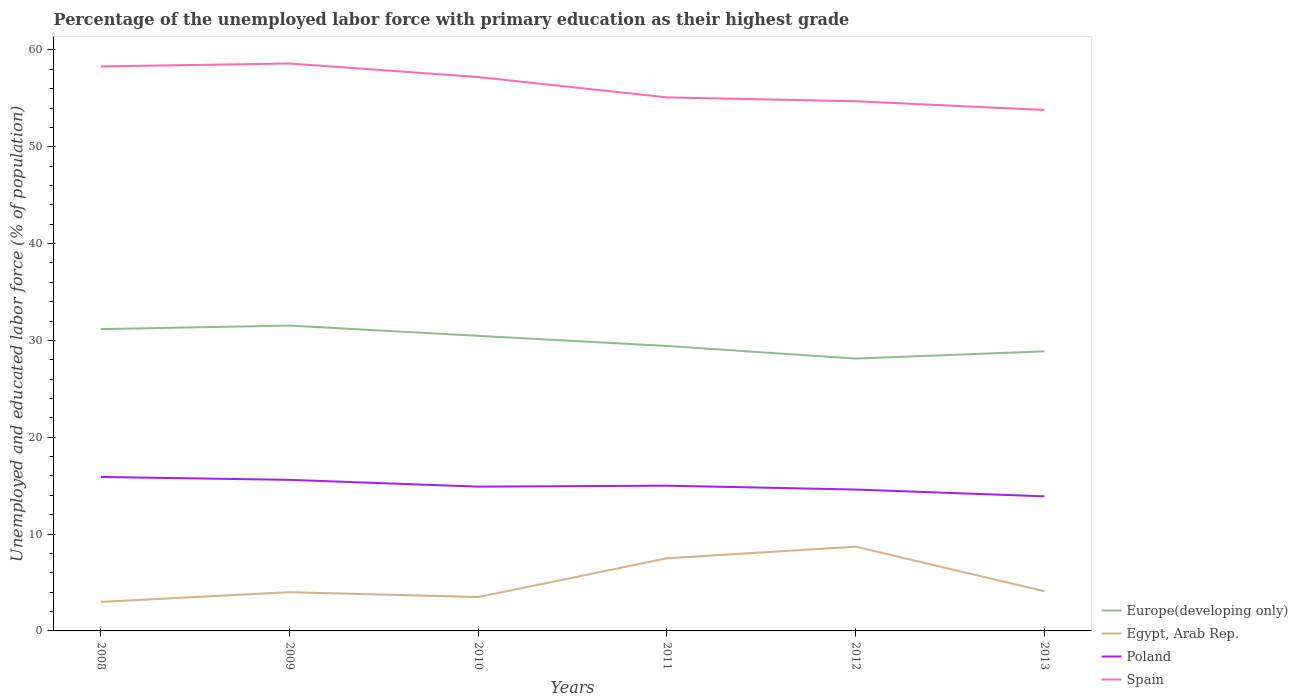How many different coloured lines are there?
Provide a succinct answer. 4. Does the line corresponding to Europe(developing only) intersect with the line corresponding to Spain?
Your answer should be compact. No. Across all years, what is the maximum percentage of the unemployed labor force with primary education in Poland?
Keep it short and to the point. 13.9. In which year was the percentage of the unemployed labor force with primary education in Europe(developing only) maximum?
Your response must be concise. 2012. What is the total percentage of the unemployed labor force with primary education in Europe(developing only) in the graph?
Your answer should be compact. 2.29. What is the difference between the highest and the second highest percentage of the unemployed labor force with primary education in Poland?
Make the answer very short. 2. How many lines are there?
Make the answer very short. 4. How many years are there in the graph?
Make the answer very short. 6. Are the values on the major ticks of Y-axis written in scientific E-notation?
Your answer should be very brief. No. How many legend labels are there?
Your response must be concise. 4. What is the title of the graph?
Provide a succinct answer. Percentage of the unemployed labor force with primary education as their highest grade. Does "Guatemala" appear as one of the legend labels in the graph?
Offer a very short reply. No. What is the label or title of the Y-axis?
Offer a terse response. Unemployed and educated labor force (% of population). What is the Unemployed and educated labor force (% of population) in Europe(developing only) in 2008?
Make the answer very short. 31.17. What is the Unemployed and educated labor force (% of population) in Egypt, Arab Rep. in 2008?
Offer a very short reply. 3. What is the Unemployed and educated labor force (% of population) in Poland in 2008?
Your response must be concise. 15.9. What is the Unemployed and educated labor force (% of population) of Spain in 2008?
Offer a very short reply. 58.3. What is the Unemployed and educated labor force (% of population) in Europe(developing only) in 2009?
Make the answer very short. 31.54. What is the Unemployed and educated labor force (% of population) in Egypt, Arab Rep. in 2009?
Offer a very short reply. 4. What is the Unemployed and educated labor force (% of population) of Poland in 2009?
Make the answer very short. 15.6. What is the Unemployed and educated labor force (% of population) in Spain in 2009?
Make the answer very short. 58.6. What is the Unemployed and educated labor force (% of population) of Europe(developing only) in 2010?
Provide a short and direct response. 30.47. What is the Unemployed and educated labor force (% of population) of Poland in 2010?
Your answer should be very brief. 14.9. What is the Unemployed and educated labor force (% of population) of Spain in 2010?
Offer a terse response. 57.2. What is the Unemployed and educated labor force (% of population) of Europe(developing only) in 2011?
Offer a very short reply. 29.43. What is the Unemployed and educated labor force (% of population) of Spain in 2011?
Provide a succinct answer. 55.1. What is the Unemployed and educated labor force (% of population) in Europe(developing only) in 2012?
Keep it short and to the point. 28.13. What is the Unemployed and educated labor force (% of population) of Egypt, Arab Rep. in 2012?
Your answer should be compact. 8.7. What is the Unemployed and educated labor force (% of population) in Poland in 2012?
Provide a short and direct response. 14.6. What is the Unemployed and educated labor force (% of population) of Spain in 2012?
Your answer should be very brief. 54.7. What is the Unemployed and educated labor force (% of population) of Europe(developing only) in 2013?
Keep it short and to the point. 28.87. What is the Unemployed and educated labor force (% of population) of Egypt, Arab Rep. in 2013?
Offer a very short reply. 4.1. What is the Unemployed and educated labor force (% of population) of Poland in 2013?
Provide a succinct answer. 13.9. What is the Unemployed and educated labor force (% of population) of Spain in 2013?
Offer a terse response. 53.8. Across all years, what is the maximum Unemployed and educated labor force (% of population) of Europe(developing only)?
Your answer should be very brief. 31.54. Across all years, what is the maximum Unemployed and educated labor force (% of population) of Egypt, Arab Rep.?
Your answer should be compact. 8.7. Across all years, what is the maximum Unemployed and educated labor force (% of population) of Poland?
Keep it short and to the point. 15.9. Across all years, what is the maximum Unemployed and educated labor force (% of population) in Spain?
Offer a terse response. 58.6. Across all years, what is the minimum Unemployed and educated labor force (% of population) in Europe(developing only)?
Give a very brief answer. 28.13. Across all years, what is the minimum Unemployed and educated labor force (% of population) in Egypt, Arab Rep.?
Provide a succinct answer. 3. Across all years, what is the minimum Unemployed and educated labor force (% of population) in Poland?
Provide a short and direct response. 13.9. Across all years, what is the minimum Unemployed and educated labor force (% of population) in Spain?
Ensure brevity in your answer.  53.8. What is the total Unemployed and educated labor force (% of population) of Europe(developing only) in the graph?
Offer a very short reply. 179.6. What is the total Unemployed and educated labor force (% of population) of Egypt, Arab Rep. in the graph?
Offer a very short reply. 30.8. What is the total Unemployed and educated labor force (% of population) in Poland in the graph?
Offer a very short reply. 89.9. What is the total Unemployed and educated labor force (% of population) of Spain in the graph?
Your answer should be compact. 337.7. What is the difference between the Unemployed and educated labor force (% of population) in Europe(developing only) in 2008 and that in 2009?
Your answer should be very brief. -0.37. What is the difference between the Unemployed and educated labor force (% of population) of Egypt, Arab Rep. in 2008 and that in 2009?
Give a very brief answer. -1. What is the difference between the Unemployed and educated labor force (% of population) in Poland in 2008 and that in 2009?
Offer a very short reply. 0.3. What is the difference between the Unemployed and educated labor force (% of population) in Spain in 2008 and that in 2009?
Your answer should be compact. -0.3. What is the difference between the Unemployed and educated labor force (% of population) of Europe(developing only) in 2008 and that in 2010?
Your answer should be compact. 0.69. What is the difference between the Unemployed and educated labor force (% of population) in Poland in 2008 and that in 2010?
Your response must be concise. 1. What is the difference between the Unemployed and educated labor force (% of population) in Spain in 2008 and that in 2010?
Offer a very short reply. 1.1. What is the difference between the Unemployed and educated labor force (% of population) of Europe(developing only) in 2008 and that in 2011?
Offer a terse response. 1.74. What is the difference between the Unemployed and educated labor force (% of population) in Poland in 2008 and that in 2011?
Offer a very short reply. 0.9. What is the difference between the Unemployed and educated labor force (% of population) in Europe(developing only) in 2008 and that in 2012?
Ensure brevity in your answer.  3.04. What is the difference between the Unemployed and educated labor force (% of population) in Europe(developing only) in 2008 and that in 2013?
Your response must be concise. 2.29. What is the difference between the Unemployed and educated labor force (% of population) in Egypt, Arab Rep. in 2008 and that in 2013?
Give a very brief answer. -1.1. What is the difference between the Unemployed and educated labor force (% of population) of Spain in 2008 and that in 2013?
Ensure brevity in your answer.  4.5. What is the difference between the Unemployed and educated labor force (% of population) of Europe(developing only) in 2009 and that in 2010?
Offer a terse response. 1.06. What is the difference between the Unemployed and educated labor force (% of population) in Egypt, Arab Rep. in 2009 and that in 2010?
Offer a very short reply. 0.5. What is the difference between the Unemployed and educated labor force (% of population) of Spain in 2009 and that in 2010?
Ensure brevity in your answer.  1.4. What is the difference between the Unemployed and educated labor force (% of population) of Europe(developing only) in 2009 and that in 2011?
Your answer should be compact. 2.11. What is the difference between the Unemployed and educated labor force (% of population) in Egypt, Arab Rep. in 2009 and that in 2011?
Ensure brevity in your answer.  -3.5. What is the difference between the Unemployed and educated labor force (% of population) of Spain in 2009 and that in 2011?
Your answer should be very brief. 3.5. What is the difference between the Unemployed and educated labor force (% of population) in Europe(developing only) in 2009 and that in 2012?
Give a very brief answer. 3.41. What is the difference between the Unemployed and educated labor force (% of population) of Egypt, Arab Rep. in 2009 and that in 2012?
Offer a very short reply. -4.7. What is the difference between the Unemployed and educated labor force (% of population) in Poland in 2009 and that in 2012?
Keep it short and to the point. 1. What is the difference between the Unemployed and educated labor force (% of population) in Europe(developing only) in 2009 and that in 2013?
Make the answer very short. 2.66. What is the difference between the Unemployed and educated labor force (% of population) of Egypt, Arab Rep. in 2009 and that in 2013?
Ensure brevity in your answer.  -0.1. What is the difference between the Unemployed and educated labor force (% of population) of Europe(developing only) in 2010 and that in 2011?
Ensure brevity in your answer.  1.04. What is the difference between the Unemployed and educated labor force (% of population) in Egypt, Arab Rep. in 2010 and that in 2011?
Your answer should be very brief. -4. What is the difference between the Unemployed and educated labor force (% of population) in Spain in 2010 and that in 2011?
Offer a very short reply. 2.1. What is the difference between the Unemployed and educated labor force (% of population) in Europe(developing only) in 2010 and that in 2012?
Your answer should be compact. 2.35. What is the difference between the Unemployed and educated labor force (% of population) of Spain in 2010 and that in 2012?
Offer a very short reply. 2.5. What is the difference between the Unemployed and educated labor force (% of population) in Europe(developing only) in 2010 and that in 2013?
Your answer should be very brief. 1.6. What is the difference between the Unemployed and educated labor force (% of population) of Poland in 2010 and that in 2013?
Your answer should be compact. 1. What is the difference between the Unemployed and educated labor force (% of population) in Europe(developing only) in 2011 and that in 2012?
Your response must be concise. 1.3. What is the difference between the Unemployed and educated labor force (% of population) of Egypt, Arab Rep. in 2011 and that in 2012?
Your response must be concise. -1.2. What is the difference between the Unemployed and educated labor force (% of population) in Poland in 2011 and that in 2012?
Offer a very short reply. 0.4. What is the difference between the Unemployed and educated labor force (% of population) of Europe(developing only) in 2011 and that in 2013?
Offer a very short reply. 0.55. What is the difference between the Unemployed and educated labor force (% of population) in Egypt, Arab Rep. in 2011 and that in 2013?
Provide a short and direct response. 3.4. What is the difference between the Unemployed and educated labor force (% of population) in Poland in 2011 and that in 2013?
Make the answer very short. 1.1. What is the difference between the Unemployed and educated labor force (% of population) of Spain in 2011 and that in 2013?
Provide a short and direct response. 1.3. What is the difference between the Unemployed and educated labor force (% of population) in Europe(developing only) in 2012 and that in 2013?
Keep it short and to the point. -0.75. What is the difference between the Unemployed and educated labor force (% of population) in Poland in 2012 and that in 2013?
Ensure brevity in your answer.  0.7. What is the difference between the Unemployed and educated labor force (% of population) of Spain in 2012 and that in 2013?
Offer a terse response. 0.9. What is the difference between the Unemployed and educated labor force (% of population) in Europe(developing only) in 2008 and the Unemployed and educated labor force (% of population) in Egypt, Arab Rep. in 2009?
Offer a very short reply. 27.17. What is the difference between the Unemployed and educated labor force (% of population) of Europe(developing only) in 2008 and the Unemployed and educated labor force (% of population) of Poland in 2009?
Offer a very short reply. 15.57. What is the difference between the Unemployed and educated labor force (% of population) of Europe(developing only) in 2008 and the Unemployed and educated labor force (% of population) of Spain in 2009?
Your answer should be compact. -27.43. What is the difference between the Unemployed and educated labor force (% of population) of Egypt, Arab Rep. in 2008 and the Unemployed and educated labor force (% of population) of Spain in 2009?
Keep it short and to the point. -55.6. What is the difference between the Unemployed and educated labor force (% of population) in Poland in 2008 and the Unemployed and educated labor force (% of population) in Spain in 2009?
Your answer should be compact. -42.7. What is the difference between the Unemployed and educated labor force (% of population) in Europe(developing only) in 2008 and the Unemployed and educated labor force (% of population) in Egypt, Arab Rep. in 2010?
Provide a short and direct response. 27.67. What is the difference between the Unemployed and educated labor force (% of population) of Europe(developing only) in 2008 and the Unemployed and educated labor force (% of population) of Poland in 2010?
Keep it short and to the point. 16.27. What is the difference between the Unemployed and educated labor force (% of population) of Europe(developing only) in 2008 and the Unemployed and educated labor force (% of population) of Spain in 2010?
Your answer should be compact. -26.03. What is the difference between the Unemployed and educated labor force (% of population) in Egypt, Arab Rep. in 2008 and the Unemployed and educated labor force (% of population) in Spain in 2010?
Provide a succinct answer. -54.2. What is the difference between the Unemployed and educated labor force (% of population) in Poland in 2008 and the Unemployed and educated labor force (% of population) in Spain in 2010?
Your answer should be very brief. -41.3. What is the difference between the Unemployed and educated labor force (% of population) in Europe(developing only) in 2008 and the Unemployed and educated labor force (% of population) in Egypt, Arab Rep. in 2011?
Your answer should be compact. 23.67. What is the difference between the Unemployed and educated labor force (% of population) in Europe(developing only) in 2008 and the Unemployed and educated labor force (% of population) in Poland in 2011?
Offer a terse response. 16.17. What is the difference between the Unemployed and educated labor force (% of population) in Europe(developing only) in 2008 and the Unemployed and educated labor force (% of population) in Spain in 2011?
Offer a terse response. -23.93. What is the difference between the Unemployed and educated labor force (% of population) in Egypt, Arab Rep. in 2008 and the Unemployed and educated labor force (% of population) in Poland in 2011?
Offer a very short reply. -12. What is the difference between the Unemployed and educated labor force (% of population) in Egypt, Arab Rep. in 2008 and the Unemployed and educated labor force (% of population) in Spain in 2011?
Your answer should be very brief. -52.1. What is the difference between the Unemployed and educated labor force (% of population) in Poland in 2008 and the Unemployed and educated labor force (% of population) in Spain in 2011?
Offer a very short reply. -39.2. What is the difference between the Unemployed and educated labor force (% of population) in Europe(developing only) in 2008 and the Unemployed and educated labor force (% of population) in Egypt, Arab Rep. in 2012?
Provide a short and direct response. 22.47. What is the difference between the Unemployed and educated labor force (% of population) in Europe(developing only) in 2008 and the Unemployed and educated labor force (% of population) in Poland in 2012?
Your answer should be very brief. 16.57. What is the difference between the Unemployed and educated labor force (% of population) of Europe(developing only) in 2008 and the Unemployed and educated labor force (% of population) of Spain in 2012?
Keep it short and to the point. -23.53. What is the difference between the Unemployed and educated labor force (% of population) of Egypt, Arab Rep. in 2008 and the Unemployed and educated labor force (% of population) of Poland in 2012?
Your answer should be very brief. -11.6. What is the difference between the Unemployed and educated labor force (% of population) of Egypt, Arab Rep. in 2008 and the Unemployed and educated labor force (% of population) of Spain in 2012?
Offer a terse response. -51.7. What is the difference between the Unemployed and educated labor force (% of population) in Poland in 2008 and the Unemployed and educated labor force (% of population) in Spain in 2012?
Your response must be concise. -38.8. What is the difference between the Unemployed and educated labor force (% of population) in Europe(developing only) in 2008 and the Unemployed and educated labor force (% of population) in Egypt, Arab Rep. in 2013?
Provide a short and direct response. 27.07. What is the difference between the Unemployed and educated labor force (% of population) in Europe(developing only) in 2008 and the Unemployed and educated labor force (% of population) in Poland in 2013?
Give a very brief answer. 17.27. What is the difference between the Unemployed and educated labor force (% of population) in Europe(developing only) in 2008 and the Unemployed and educated labor force (% of population) in Spain in 2013?
Provide a succinct answer. -22.63. What is the difference between the Unemployed and educated labor force (% of population) in Egypt, Arab Rep. in 2008 and the Unemployed and educated labor force (% of population) in Poland in 2013?
Your answer should be very brief. -10.9. What is the difference between the Unemployed and educated labor force (% of population) in Egypt, Arab Rep. in 2008 and the Unemployed and educated labor force (% of population) in Spain in 2013?
Make the answer very short. -50.8. What is the difference between the Unemployed and educated labor force (% of population) of Poland in 2008 and the Unemployed and educated labor force (% of population) of Spain in 2013?
Give a very brief answer. -37.9. What is the difference between the Unemployed and educated labor force (% of population) of Europe(developing only) in 2009 and the Unemployed and educated labor force (% of population) of Egypt, Arab Rep. in 2010?
Your answer should be very brief. 28.04. What is the difference between the Unemployed and educated labor force (% of population) of Europe(developing only) in 2009 and the Unemployed and educated labor force (% of population) of Poland in 2010?
Ensure brevity in your answer.  16.64. What is the difference between the Unemployed and educated labor force (% of population) in Europe(developing only) in 2009 and the Unemployed and educated labor force (% of population) in Spain in 2010?
Give a very brief answer. -25.66. What is the difference between the Unemployed and educated labor force (% of population) in Egypt, Arab Rep. in 2009 and the Unemployed and educated labor force (% of population) in Spain in 2010?
Your answer should be very brief. -53.2. What is the difference between the Unemployed and educated labor force (% of population) in Poland in 2009 and the Unemployed and educated labor force (% of population) in Spain in 2010?
Provide a short and direct response. -41.6. What is the difference between the Unemployed and educated labor force (% of population) of Europe(developing only) in 2009 and the Unemployed and educated labor force (% of population) of Egypt, Arab Rep. in 2011?
Provide a succinct answer. 24.04. What is the difference between the Unemployed and educated labor force (% of population) of Europe(developing only) in 2009 and the Unemployed and educated labor force (% of population) of Poland in 2011?
Offer a very short reply. 16.54. What is the difference between the Unemployed and educated labor force (% of population) in Europe(developing only) in 2009 and the Unemployed and educated labor force (% of population) in Spain in 2011?
Keep it short and to the point. -23.56. What is the difference between the Unemployed and educated labor force (% of population) of Egypt, Arab Rep. in 2009 and the Unemployed and educated labor force (% of population) of Poland in 2011?
Provide a succinct answer. -11. What is the difference between the Unemployed and educated labor force (% of population) of Egypt, Arab Rep. in 2009 and the Unemployed and educated labor force (% of population) of Spain in 2011?
Offer a terse response. -51.1. What is the difference between the Unemployed and educated labor force (% of population) of Poland in 2009 and the Unemployed and educated labor force (% of population) of Spain in 2011?
Your answer should be compact. -39.5. What is the difference between the Unemployed and educated labor force (% of population) in Europe(developing only) in 2009 and the Unemployed and educated labor force (% of population) in Egypt, Arab Rep. in 2012?
Your answer should be compact. 22.84. What is the difference between the Unemployed and educated labor force (% of population) in Europe(developing only) in 2009 and the Unemployed and educated labor force (% of population) in Poland in 2012?
Make the answer very short. 16.94. What is the difference between the Unemployed and educated labor force (% of population) of Europe(developing only) in 2009 and the Unemployed and educated labor force (% of population) of Spain in 2012?
Your response must be concise. -23.16. What is the difference between the Unemployed and educated labor force (% of population) of Egypt, Arab Rep. in 2009 and the Unemployed and educated labor force (% of population) of Spain in 2012?
Ensure brevity in your answer.  -50.7. What is the difference between the Unemployed and educated labor force (% of population) of Poland in 2009 and the Unemployed and educated labor force (% of population) of Spain in 2012?
Provide a succinct answer. -39.1. What is the difference between the Unemployed and educated labor force (% of population) in Europe(developing only) in 2009 and the Unemployed and educated labor force (% of population) in Egypt, Arab Rep. in 2013?
Make the answer very short. 27.44. What is the difference between the Unemployed and educated labor force (% of population) in Europe(developing only) in 2009 and the Unemployed and educated labor force (% of population) in Poland in 2013?
Your answer should be compact. 17.64. What is the difference between the Unemployed and educated labor force (% of population) in Europe(developing only) in 2009 and the Unemployed and educated labor force (% of population) in Spain in 2013?
Your answer should be compact. -22.26. What is the difference between the Unemployed and educated labor force (% of population) in Egypt, Arab Rep. in 2009 and the Unemployed and educated labor force (% of population) in Spain in 2013?
Make the answer very short. -49.8. What is the difference between the Unemployed and educated labor force (% of population) of Poland in 2009 and the Unemployed and educated labor force (% of population) of Spain in 2013?
Make the answer very short. -38.2. What is the difference between the Unemployed and educated labor force (% of population) in Europe(developing only) in 2010 and the Unemployed and educated labor force (% of population) in Egypt, Arab Rep. in 2011?
Make the answer very short. 22.97. What is the difference between the Unemployed and educated labor force (% of population) in Europe(developing only) in 2010 and the Unemployed and educated labor force (% of population) in Poland in 2011?
Your answer should be compact. 15.47. What is the difference between the Unemployed and educated labor force (% of population) in Europe(developing only) in 2010 and the Unemployed and educated labor force (% of population) in Spain in 2011?
Offer a terse response. -24.63. What is the difference between the Unemployed and educated labor force (% of population) in Egypt, Arab Rep. in 2010 and the Unemployed and educated labor force (% of population) in Poland in 2011?
Provide a short and direct response. -11.5. What is the difference between the Unemployed and educated labor force (% of population) of Egypt, Arab Rep. in 2010 and the Unemployed and educated labor force (% of population) of Spain in 2011?
Your response must be concise. -51.6. What is the difference between the Unemployed and educated labor force (% of population) of Poland in 2010 and the Unemployed and educated labor force (% of population) of Spain in 2011?
Ensure brevity in your answer.  -40.2. What is the difference between the Unemployed and educated labor force (% of population) in Europe(developing only) in 2010 and the Unemployed and educated labor force (% of population) in Egypt, Arab Rep. in 2012?
Ensure brevity in your answer.  21.77. What is the difference between the Unemployed and educated labor force (% of population) of Europe(developing only) in 2010 and the Unemployed and educated labor force (% of population) of Poland in 2012?
Give a very brief answer. 15.87. What is the difference between the Unemployed and educated labor force (% of population) in Europe(developing only) in 2010 and the Unemployed and educated labor force (% of population) in Spain in 2012?
Ensure brevity in your answer.  -24.23. What is the difference between the Unemployed and educated labor force (% of population) of Egypt, Arab Rep. in 2010 and the Unemployed and educated labor force (% of population) of Spain in 2012?
Your answer should be very brief. -51.2. What is the difference between the Unemployed and educated labor force (% of population) of Poland in 2010 and the Unemployed and educated labor force (% of population) of Spain in 2012?
Your response must be concise. -39.8. What is the difference between the Unemployed and educated labor force (% of population) of Europe(developing only) in 2010 and the Unemployed and educated labor force (% of population) of Egypt, Arab Rep. in 2013?
Ensure brevity in your answer.  26.37. What is the difference between the Unemployed and educated labor force (% of population) of Europe(developing only) in 2010 and the Unemployed and educated labor force (% of population) of Poland in 2013?
Provide a succinct answer. 16.57. What is the difference between the Unemployed and educated labor force (% of population) of Europe(developing only) in 2010 and the Unemployed and educated labor force (% of population) of Spain in 2013?
Provide a short and direct response. -23.33. What is the difference between the Unemployed and educated labor force (% of population) in Egypt, Arab Rep. in 2010 and the Unemployed and educated labor force (% of population) in Poland in 2013?
Give a very brief answer. -10.4. What is the difference between the Unemployed and educated labor force (% of population) of Egypt, Arab Rep. in 2010 and the Unemployed and educated labor force (% of population) of Spain in 2013?
Ensure brevity in your answer.  -50.3. What is the difference between the Unemployed and educated labor force (% of population) of Poland in 2010 and the Unemployed and educated labor force (% of population) of Spain in 2013?
Offer a terse response. -38.9. What is the difference between the Unemployed and educated labor force (% of population) of Europe(developing only) in 2011 and the Unemployed and educated labor force (% of population) of Egypt, Arab Rep. in 2012?
Make the answer very short. 20.73. What is the difference between the Unemployed and educated labor force (% of population) of Europe(developing only) in 2011 and the Unemployed and educated labor force (% of population) of Poland in 2012?
Make the answer very short. 14.83. What is the difference between the Unemployed and educated labor force (% of population) of Europe(developing only) in 2011 and the Unemployed and educated labor force (% of population) of Spain in 2012?
Your answer should be compact. -25.27. What is the difference between the Unemployed and educated labor force (% of population) in Egypt, Arab Rep. in 2011 and the Unemployed and educated labor force (% of population) in Poland in 2012?
Your response must be concise. -7.1. What is the difference between the Unemployed and educated labor force (% of population) of Egypt, Arab Rep. in 2011 and the Unemployed and educated labor force (% of population) of Spain in 2012?
Offer a terse response. -47.2. What is the difference between the Unemployed and educated labor force (% of population) in Poland in 2011 and the Unemployed and educated labor force (% of population) in Spain in 2012?
Offer a terse response. -39.7. What is the difference between the Unemployed and educated labor force (% of population) of Europe(developing only) in 2011 and the Unemployed and educated labor force (% of population) of Egypt, Arab Rep. in 2013?
Ensure brevity in your answer.  25.33. What is the difference between the Unemployed and educated labor force (% of population) in Europe(developing only) in 2011 and the Unemployed and educated labor force (% of population) in Poland in 2013?
Make the answer very short. 15.53. What is the difference between the Unemployed and educated labor force (% of population) in Europe(developing only) in 2011 and the Unemployed and educated labor force (% of population) in Spain in 2013?
Your answer should be compact. -24.37. What is the difference between the Unemployed and educated labor force (% of population) of Egypt, Arab Rep. in 2011 and the Unemployed and educated labor force (% of population) of Poland in 2013?
Your response must be concise. -6.4. What is the difference between the Unemployed and educated labor force (% of population) of Egypt, Arab Rep. in 2011 and the Unemployed and educated labor force (% of population) of Spain in 2013?
Ensure brevity in your answer.  -46.3. What is the difference between the Unemployed and educated labor force (% of population) in Poland in 2011 and the Unemployed and educated labor force (% of population) in Spain in 2013?
Keep it short and to the point. -38.8. What is the difference between the Unemployed and educated labor force (% of population) in Europe(developing only) in 2012 and the Unemployed and educated labor force (% of population) in Egypt, Arab Rep. in 2013?
Make the answer very short. 24.03. What is the difference between the Unemployed and educated labor force (% of population) of Europe(developing only) in 2012 and the Unemployed and educated labor force (% of population) of Poland in 2013?
Make the answer very short. 14.23. What is the difference between the Unemployed and educated labor force (% of population) of Europe(developing only) in 2012 and the Unemployed and educated labor force (% of population) of Spain in 2013?
Your response must be concise. -25.67. What is the difference between the Unemployed and educated labor force (% of population) in Egypt, Arab Rep. in 2012 and the Unemployed and educated labor force (% of population) in Poland in 2013?
Your answer should be very brief. -5.2. What is the difference between the Unemployed and educated labor force (% of population) of Egypt, Arab Rep. in 2012 and the Unemployed and educated labor force (% of population) of Spain in 2013?
Give a very brief answer. -45.1. What is the difference between the Unemployed and educated labor force (% of population) of Poland in 2012 and the Unemployed and educated labor force (% of population) of Spain in 2013?
Provide a succinct answer. -39.2. What is the average Unemployed and educated labor force (% of population) of Europe(developing only) per year?
Give a very brief answer. 29.93. What is the average Unemployed and educated labor force (% of population) in Egypt, Arab Rep. per year?
Offer a very short reply. 5.13. What is the average Unemployed and educated labor force (% of population) in Poland per year?
Offer a very short reply. 14.98. What is the average Unemployed and educated labor force (% of population) in Spain per year?
Make the answer very short. 56.28. In the year 2008, what is the difference between the Unemployed and educated labor force (% of population) of Europe(developing only) and Unemployed and educated labor force (% of population) of Egypt, Arab Rep.?
Keep it short and to the point. 28.17. In the year 2008, what is the difference between the Unemployed and educated labor force (% of population) in Europe(developing only) and Unemployed and educated labor force (% of population) in Poland?
Ensure brevity in your answer.  15.27. In the year 2008, what is the difference between the Unemployed and educated labor force (% of population) in Europe(developing only) and Unemployed and educated labor force (% of population) in Spain?
Your answer should be very brief. -27.13. In the year 2008, what is the difference between the Unemployed and educated labor force (% of population) of Egypt, Arab Rep. and Unemployed and educated labor force (% of population) of Spain?
Ensure brevity in your answer.  -55.3. In the year 2008, what is the difference between the Unemployed and educated labor force (% of population) in Poland and Unemployed and educated labor force (% of population) in Spain?
Offer a terse response. -42.4. In the year 2009, what is the difference between the Unemployed and educated labor force (% of population) of Europe(developing only) and Unemployed and educated labor force (% of population) of Egypt, Arab Rep.?
Give a very brief answer. 27.54. In the year 2009, what is the difference between the Unemployed and educated labor force (% of population) in Europe(developing only) and Unemployed and educated labor force (% of population) in Poland?
Your response must be concise. 15.94. In the year 2009, what is the difference between the Unemployed and educated labor force (% of population) of Europe(developing only) and Unemployed and educated labor force (% of population) of Spain?
Your answer should be compact. -27.06. In the year 2009, what is the difference between the Unemployed and educated labor force (% of population) in Egypt, Arab Rep. and Unemployed and educated labor force (% of population) in Poland?
Provide a succinct answer. -11.6. In the year 2009, what is the difference between the Unemployed and educated labor force (% of population) of Egypt, Arab Rep. and Unemployed and educated labor force (% of population) of Spain?
Ensure brevity in your answer.  -54.6. In the year 2009, what is the difference between the Unemployed and educated labor force (% of population) of Poland and Unemployed and educated labor force (% of population) of Spain?
Your answer should be very brief. -43. In the year 2010, what is the difference between the Unemployed and educated labor force (% of population) of Europe(developing only) and Unemployed and educated labor force (% of population) of Egypt, Arab Rep.?
Ensure brevity in your answer.  26.97. In the year 2010, what is the difference between the Unemployed and educated labor force (% of population) of Europe(developing only) and Unemployed and educated labor force (% of population) of Poland?
Your answer should be compact. 15.57. In the year 2010, what is the difference between the Unemployed and educated labor force (% of population) of Europe(developing only) and Unemployed and educated labor force (% of population) of Spain?
Provide a short and direct response. -26.73. In the year 2010, what is the difference between the Unemployed and educated labor force (% of population) of Egypt, Arab Rep. and Unemployed and educated labor force (% of population) of Spain?
Your response must be concise. -53.7. In the year 2010, what is the difference between the Unemployed and educated labor force (% of population) of Poland and Unemployed and educated labor force (% of population) of Spain?
Your response must be concise. -42.3. In the year 2011, what is the difference between the Unemployed and educated labor force (% of population) of Europe(developing only) and Unemployed and educated labor force (% of population) of Egypt, Arab Rep.?
Provide a succinct answer. 21.93. In the year 2011, what is the difference between the Unemployed and educated labor force (% of population) of Europe(developing only) and Unemployed and educated labor force (% of population) of Poland?
Your answer should be very brief. 14.43. In the year 2011, what is the difference between the Unemployed and educated labor force (% of population) of Europe(developing only) and Unemployed and educated labor force (% of population) of Spain?
Your answer should be very brief. -25.67. In the year 2011, what is the difference between the Unemployed and educated labor force (% of population) in Egypt, Arab Rep. and Unemployed and educated labor force (% of population) in Spain?
Provide a succinct answer. -47.6. In the year 2011, what is the difference between the Unemployed and educated labor force (% of population) of Poland and Unemployed and educated labor force (% of population) of Spain?
Offer a very short reply. -40.1. In the year 2012, what is the difference between the Unemployed and educated labor force (% of population) in Europe(developing only) and Unemployed and educated labor force (% of population) in Egypt, Arab Rep.?
Keep it short and to the point. 19.43. In the year 2012, what is the difference between the Unemployed and educated labor force (% of population) in Europe(developing only) and Unemployed and educated labor force (% of population) in Poland?
Make the answer very short. 13.53. In the year 2012, what is the difference between the Unemployed and educated labor force (% of population) of Europe(developing only) and Unemployed and educated labor force (% of population) of Spain?
Ensure brevity in your answer.  -26.57. In the year 2012, what is the difference between the Unemployed and educated labor force (% of population) in Egypt, Arab Rep. and Unemployed and educated labor force (% of population) in Spain?
Make the answer very short. -46. In the year 2012, what is the difference between the Unemployed and educated labor force (% of population) in Poland and Unemployed and educated labor force (% of population) in Spain?
Your response must be concise. -40.1. In the year 2013, what is the difference between the Unemployed and educated labor force (% of population) of Europe(developing only) and Unemployed and educated labor force (% of population) of Egypt, Arab Rep.?
Your answer should be compact. 24.77. In the year 2013, what is the difference between the Unemployed and educated labor force (% of population) of Europe(developing only) and Unemployed and educated labor force (% of population) of Poland?
Offer a terse response. 14.97. In the year 2013, what is the difference between the Unemployed and educated labor force (% of population) of Europe(developing only) and Unemployed and educated labor force (% of population) of Spain?
Give a very brief answer. -24.93. In the year 2013, what is the difference between the Unemployed and educated labor force (% of population) in Egypt, Arab Rep. and Unemployed and educated labor force (% of population) in Poland?
Offer a very short reply. -9.8. In the year 2013, what is the difference between the Unemployed and educated labor force (% of population) of Egypt, Arab Rep. and Unemployed and educated labor force (% of population) of Spain?
Your answer should be very brief. -49.7. In the year 2013, what is the difference between the Unemployed and educated labor force (% of population) of Poland and Unemployed and educated labor force (% of population) of Spain?
Give a very brief answer. -39.9. What is the ratio of the Unemployed and educated labor force (% of population) in Europe(developing only) in 2008 to that in 2009?
Offer a very short reply. 0.99. What is the ratio of the Unemployed and educated labor force (% of population) in Egypt, Arab Rep. in 2008 to that in 2009?
Make the answer very short. 0.75. What is the ratio of the Unemployed and educated labor force (% of population) in Poland in 2008 to that in 2009?
Ensure brevity in your answer.  1.02. What is the ratio of the Unemployed and educated labor force (% of population) of Spain in 2008 to that in 2009?
Offer a very short reply. 0.99. What is the ratio of the Unemployed and educated labor force (% of population) of Europe(developing only) in 2008 to that in 2010?
Offer a terse response. 1.02. What is the ratio of the Unemployed and educated labor force (% of population) of Egypt, Arab Rep. in 2008 to that in 2010?
Offer a very short reply. 0.86. What is the ratio of the Unemployed and educated labor force (% of population) of Poland in 2008 to that in 2010?
Provide a succinct answer. 1.07. What is the ratio of the Unemployed and educated labor force (% of population) of Spain in 2008 to that in 2010?
Provide a succinct answer. 1.02. What is the ratio of the Unemployed and educated labor force (% of population) in Europe(developing only) in 2008 to that in 2011?
Give a very brief answer. 1.06. What is the ratio of the Unemployed and educated labor force (% of population) in Egypt, Arab Rep. in 2008 to that in 2011?
Offer a terse response. 0.4. What is the ratio of the Unemployed and educated labor force (% of population) in Poland in 2008 to that in 2011?
Provide a short and direct response. 1.06. What is the ratio of the Unemployed and educated labor force (% of population) in Spain in 2008 to that in 2011?
Your answer should be very brief. 1.06. What is the ratio of the Unemployed and educated labor force (% of population) of Europe(developing only) in 2008 to that in 2012?
Offer a very short reply. 1.11. What is the ratio of the Unemployed and educated labor force (% of population) in Egypt, Arab Rep. in 2008 to that in 2012?
Offer a very short reply. 0.34. What is the ratio of the Unemployed and educated labor force (% of population) in Poland in 2008 to that in 2012?
Offer a terse response. 1.09. What is the ratio of the Unemployed and educated labor force (% of population) in Spain in 2008 to that in 2012?
Keep it short and to the point. 1.07. What is the ratio of the Unemployed and educated labor force (% of population) of Europe(developing only) in 2008 to that in 2013?
Make the answer very short. 1.08. What is the ratio of the Unemployed and educated labor force (% of population) in Egypt, Arab Rep. in 2008 to that in 2013?
Offer a very short reply. 0.73. What is the ratio of the Unemployed and educated labor force (% of population) in Poland in 2008 to that in 2013?
Offer a terse response. 1.14. What is the ratio of the Unemployed and educated labor force (% of population) of Spain in 2008 to that in 2013?
Give a very brief answer. 1.08. What is the ratio of the Unemployed and educated labor force (% of population) in Europe(developing only) in 2009 to that in 2010?
Your answer should be compact. 1.03. What is the ratio of the Unemployed and educated labor force (% of population) of Egypt, Arab Rep. in 2009 to that in 2010?
Provide a short and direct response. 1.14. What is the ratio of the Unemployed and educated labor force (% of population) in Poland in 2009 to that in 2010?
Your answer should be very brief. 1.05. What is the ratio of the Unemployed and educated labor force (% of population) in Spain in 2009 to that in 2010?
Provide a short and direct response. 1.02. What is the ratio of the Unemployed and educated labor force (% of population) of Europe(developing only) in 2009 to that in 2011?
Keep it short and to the point. 1.07. What is the ratio of the Unemployed and educated labor force (% of population) in Egypt, Arab Rep. in 2009 to that in 2011?
Your answer should be very brief. 0.53. What is the ratio of the Unemployed and educated labor force (% of population) in Spain in 2009 to that in 2011?
Your response must be concise. 1.06. What is the ratio of the Unemployed and educated labor force (% of population) in Europe(developing only) in 2009 to that in 2012?
Give a very brief answer. 1.12. What is the ratio of the Unemployed and educated labor force (% of population) in Egypt, Arab Rep. in 2009 to that in 2012?
Offer a very short reply. 0.46. What is the ratio of the Unemployed and educated labor force (% of population) in Poland in 2009 to that in 2012?
Give a very brief answer. 1.07. What is the ratio of the Unemployed and educated labor force (% of population) of Spain in 2009 to that in 2012?
Ensure brevity in your answer.  1.07. What is the ratio of the Unemployed and educated labor force (% of population) of Europe(developing only) in 2009 to that in 2013?
Provide a short and direct response. 1.09. What is the ratio of the Unemployed and educated labor force (% of population) in Egypt, Arab Rep. in 2009 to that in 2013?
Ensure brevity in your answer.  0.98. What is the ratio of the Unemployed and educated labor force (% of population) in Poland in 2009 to that in 2013?
Offer a very short reply. 1.12. What is the ratio of the Unemployed and educated labor force (% of population) in Spain in 2009 to that in 2013?
Your answer should be compact. 1.09. What is the ratio of the Unemployed and educated labor force (% of population) in Europe(developing only) in 2010 to that in 2011?
Your response must be concise. 1.04. What is the ratio of the Unemployed and educated labor force (% of population) in Egypt, Arab Rep. in 2010 to that in 2011?
Offer a terse response. 0.47. What is the ratio of the Unemployed and educated labor force (% of population) of Poland in 2010 to that in 2011?
Offer a very short reply. 0.99. What is the ratio of the Unemployed and educated labor force (% of population) of Spain in 2010 to that in 2011?
Give a very brief answer. 1.04. What is the ratio of the Unemployed and educated labor force (% of population) of Europe(developing only) in 2010 to that in 2012?
Give a very brief answer. 1.08. What is the ratio of the Unemployed and educated labor force (% of population) in Egypt, Arab Rep. in 2010 to that in 2012?
Offer a terse response. 0.4. What is the ratio of the Unemployed and educated labor force (% of population) of Poland in 2010 to that in 2012?
Keep it short and to the point. 1.02. What is the ratio of the Unemployed and educated labor force (% of population) of Spain in 2010 to that in 2012?
Provide a short and direct response. 1.05. What is the ratio of the Unemployed and educated labor force (% of population) of Europe(developing only) in 2010 to that in 2013?
Provide a short and direct response. 1.06. What is the ratio of the Unemployed and educated labor force (% of population) of Egypt, Arab Rep. in 2010 to that in 2013?
Your answer should be compact. 0.85. What is the ratio of the Unemployed and educated labor force (% of population) of Poland in 2010 to that in 2013?
Offer a terse response. 1.07. What is the ratio of the Unemployed and educated labor force (% of population) in Spain in 2010 to that in 2013?
Offer a terse response. 1.06. What is the ratio of the Unemployed and educated labor force (% of population) in Europe(developing only) in 2011 to that in 2012?
Ensure brevity in your answer.  1.05. What is the ratio of the Unemployed and educated labor force (% of population) of Egypt, Arab Rep. in 2011 to that in 2012?
Offer a terse response. 0.86. What is the ratio of the Unemployed and educated labor force (% of population) in Poland in 2011 to that in 2012?
Ensure brevity in your answer.  1.03. What is the ratio of the Unemployed and educated labor force (% of population) in Spain in 2011 to that in 2012?
Give a very brief answer. 1.01. What is the ratio of the Unemployed and educated labor force (% of population) in Europe(developing only) in 2011 to that in 2013?
Provide a short and direct response. 1.02. What is the ratio of the Unemployed and educated labor force (% of population) of Egypt, Arab Rep. in 2011 to that in 2013?
Offer a very short reply. 1.83. What is the ratio of the Unemployed and educated labor force (% of population) of Poland in 2011 to that in 2013?
Keep it short and to the point. 1.08. What is the ratio of the Unemployed and educated labor force (% of population) in Spain in 2011 to that in 2013?
Your response must be concise. 1.02. What is the ratio of the Unemployed and educated labor force (% of population) of Europe(developing only) in 2012 to that in 2013?
Ensure brevity in your answer.  0.97. What is the ratio of the Unemployed and educated labor force (% of population) in Egypt, Arab Rep. in 2012 to that in 2013?
Give a very brief answer. 2.12. What is the ratio of the Unemployed and educated labor force (% of population) of Poland in 2012 to that in 2013?
Provide a short and direct response. 1.05. What is the ratio of the Unemployed and educated labor force (% of population) in Spain in 2012 to that in 2013?
Make the answer very short. 1.02. What is the difference between the highest and the second highest Unemployed and educated labor force (% of population) in Europe(developing only)?
Provide a short and direct response. 0.37. What is the difference between the highest and the second highest Unemployed and educated labor force (% of population) of Egypt, Arab Rep.?
Your answer should be compact. 1.2. What is the difference between the highest and the second highest Unemployed and educated labor force (% of population) in Poland?
Ensure brevity in your answer.  0.3. What is the difference between the highest and the second highest Unemployed and educated labor force (% of population) in Spain?
Make the answer very short. 0.3. What is the difference between the highest and the lowest Unemployed and educated labor force (% of population) of Europe(developing only)?
Offer a very short reply. 3.41. What is the difference between the highest and the lowest Unemployed and educated labor force (% of population) in Egypt, Arab Rep.?
Offer a very short reply. 5.7. What is the difference between the highest and the lowest Unemployed and educated labor force (% of population) of Poland?
Keep it short and to the point. 2. 